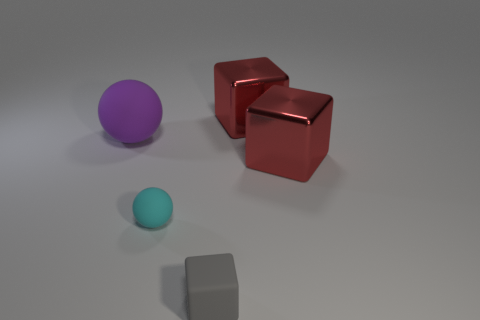Subtract all large red blocks. How many blocks are left? 1 Add 4 cyan things. How many objects exist? 9 Subtract all spheres. How many objects are left? 3 Subtract all cyan spheres. How many spheres are left? 1 Add 3 tiny things. How many tiny things are left? 5 Add 4 large purple rubber balls. How many large purple rubber balls exist? 5 Subtract 0 blue cubes. How many objects are left? 5 Subtract 2 balls. How many balls are left? 0 Subtract all cyan balls. Subtract all gray blocks. How many balls are left? 1 Subtract all purple balls. How many red cubes are left? 2 